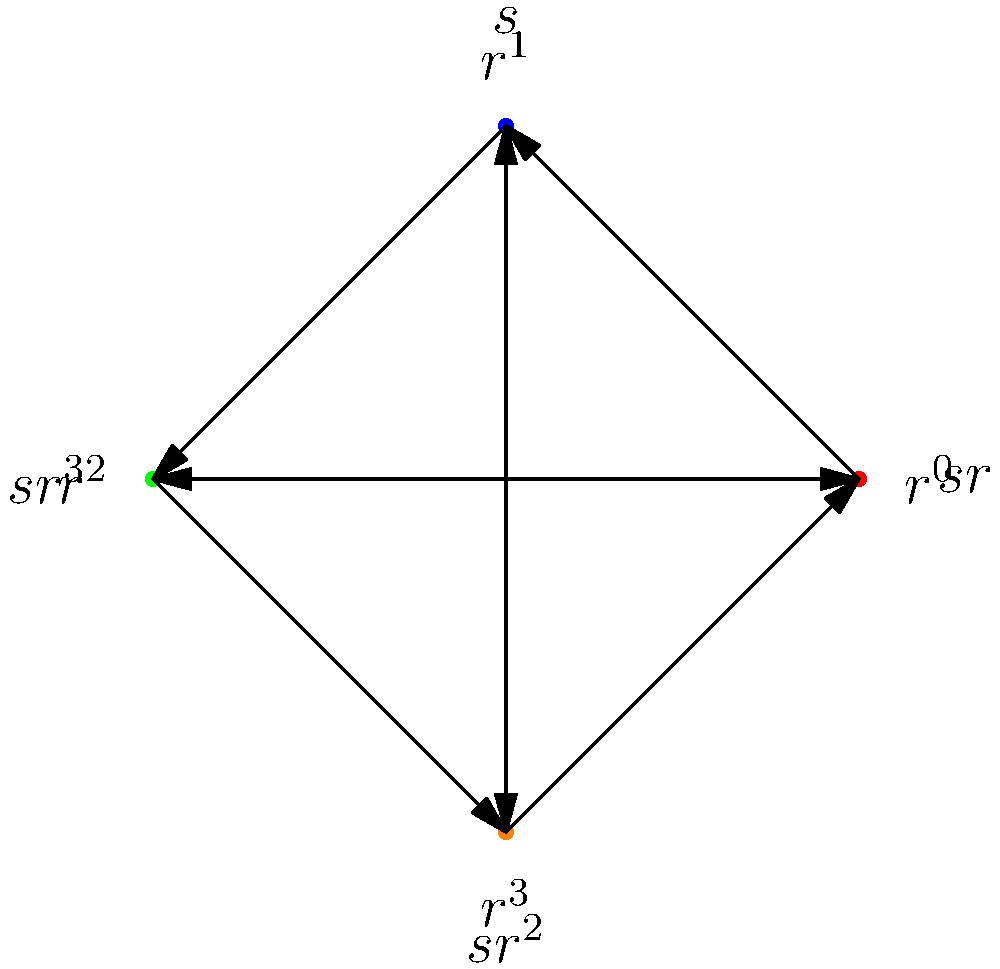Consider the Cayley graph of the dihedral group $D_4$ shown above, where $r$ represents a rotation and $s$ represents a reflection. What is the order of the element $sr$ in $D_4$? To find the order of $sr$ in $D_4$, we need to follow these steps:

1) First, recall that the order of an element is the smallest positive integer $n$ such that $(sr)^n = e$, where $e$ is the identity element.

2) Let's compute the powers of $sr$:
   $(sr)^1 = sr$
   $(sr)^2 = (sr)(sr) = s(rs)r = s(sr^{-1})r = sr^2$
   $(sr)^3 = (sr)(sr^2) = s(rs)r^2 = s(sr^{-1})r^2 = sr^3$
   $(sr)^4 = (sr)(sr^3) = s(rs)r^3 = s(sr^{-1})r^3 = sr^4 = s$

3) We can see that $(sr)^4 = s \neq e$, so we need to continue:
   $(sr)^5 = (sr)(s) = r$
   $(sr)^6 = (sr)(r) = sr^2$
   $(sr)^7 = (sr)(sr^2) = sr^3$
   $(sr)^8 = (sr)(sr^3) = s$

4) Continuing this pattern, we see that $(sr)^8 = s$, $(sr)^9 = r$, and so on.

5) The first time we get back to the identity element $e$ is after applying $sr$ eight times:
   $(sr)^8 = (sr)^4(sr)^4 = s^2 = e$

Therefore, the order of $sr$ in $D_4$ is 8.
Answer: 8 